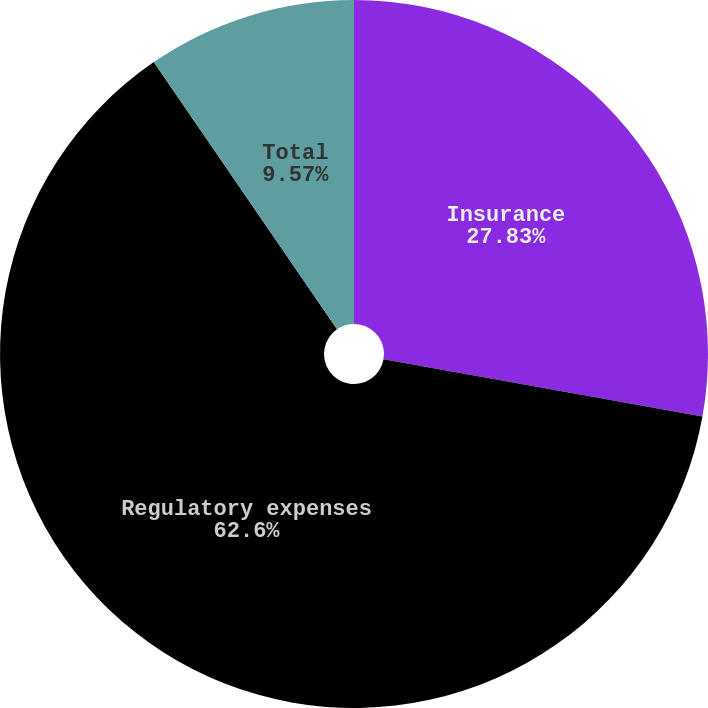Convert chart to OTSL. <chart><loc_0><loc_0><loc_500><loc_500><pie_chart><fcel>Insurance<fcel>Regulatory expenses<fcel>Total<nl><fcel>27.83%<fcel>62.61%<fcel>9.57%<nl></chart> 